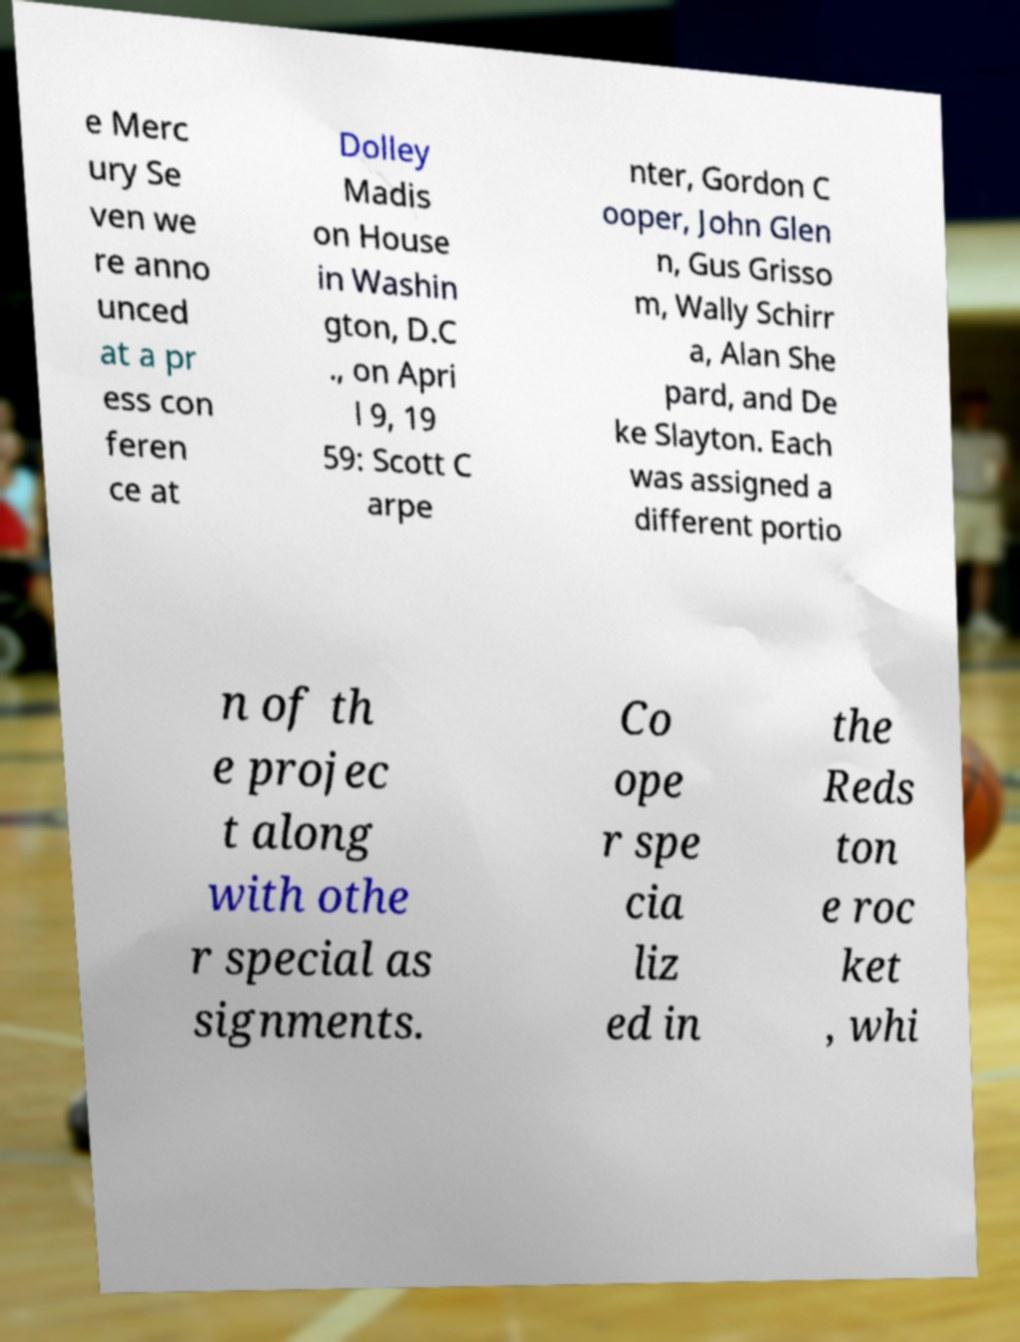Could you assist in decoding the text presented in this image and type it out clearly? e Merc ury Se ven we re anno unced at a pr ess con feren ce at Dolley Madis on House in Washin gton, D.C ., on Apri l 9, 19 59: Scott C arpe nter, Gordon C ooper, John Glen n, Gus Grisso m, Wally Schirr a, Alan She pard, and De ke Slayton. Each was assigned a different portio n of th e projec t along with othe r special as signments. Co ope r spe cia liz ed in the Reds ton e roc ket , whi 